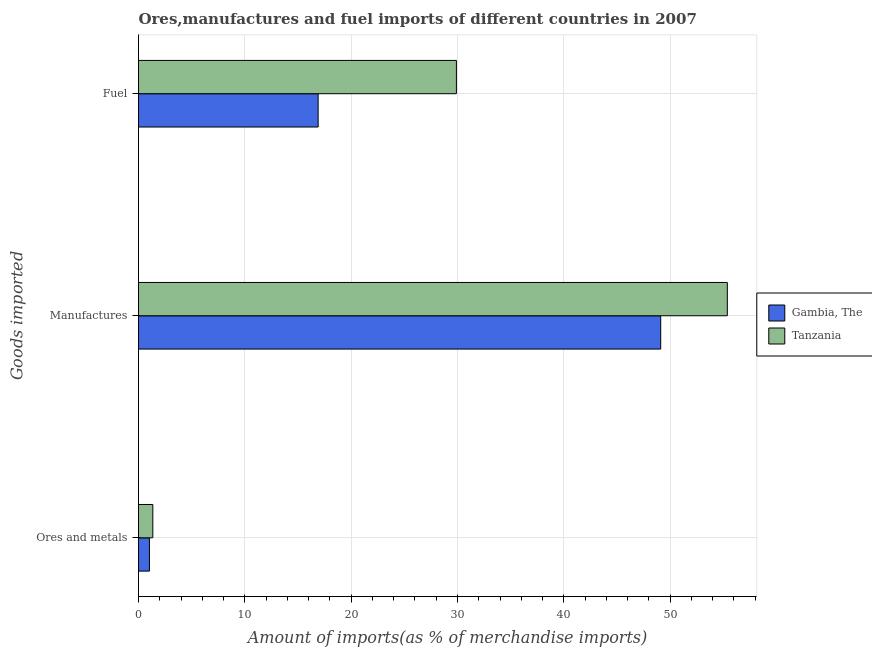Are the number of bars on each tick of the Y-axis equal?
Give a very brief answer. Yes. What is the label of the 1st group of bars from the top?
Provide a succinct answer. Fuel. What is the percentage of fuel imports in Tanzania?
Offer a terse response. 29.9. Across all countries, what is the maximum percentage of ores and metals imports?
Your answer should be very brief. 1.35. Across all countries, what is the minimum percentage of manufactures imports?
Offer a very short reply. 49.11. In which country was the percentage of fuel imports maximum?
Make the answer very short. Tanzania. In which country was the percentage of fuel imports minimum?
Make the answer very short. Gambia, The. What is the total percentage of fuel imports in the graph?
Offer a terse response. 46.79. What is the difference between the percentage of fuel imports in Tanzania and that in Gambia, The?
Give a very brief answer. 13. What is the difference between the percentage of manufactures imports in Tanzania and the percentage of fuel imports in Gambia, The?
Provide a short and direct response. 38.48. What is the average percentage of manufactures imports per country?
Your answer should be compact. 52.25. What is the difference between the percentage of manufactures imports and percentage of fuel imports in Gambia, The?
Offer a very short reply. 32.22. In how many countries, is the percentage of ores and metals imports greater than 30 %?
Ensure brevity in your answer.  0. What is the ratio of the percentage of manufactures imports in Gambia, The to that in Tanzania?
Give a very brief answer. 0.89. Is the percentage of manufactures imports in Tanzania less than that in Gambia, The?
Provide a short and direct response. No. Is the difference between the percentage of ores and metals imports in Tanzania and Gambia, The greater than the difference between the percentage of fuel imports in Tanzania and Gambia, The?
Offer a very short reply. No. What is the difference between the highest and the second highest percentage of fuel imports?
Provide a short and direct response. 13. What is the difference between the highest and the lowest percentage of ores and metals imports?
Keep it short and to the point. 0.32. What does the 1st bar from the top in Manufactures represents?
Make the answer very short. Tanzania. What does the 2nd bar from the bottom in Fuel represents?
Your answer should be compact. Tanzania. Is it the case that in every country, the sum of the percentage of ores and metals imports and percentage of manufactures imports is greater than the percentage of fuel imports?
Offer a very short reply. Yes. How many bars are there?
Offer a very short reply. 6. What is the difference between two consecutive major ticks on the X-axis?
Your response must be concise. 10. Does the graph contain any zero values?
Provide a short and direct response. No. How many legend labels are there?
Provide a succinct answer. 2. How are the legend labels stacked?
Make the answer very short. Vertical. What is the title of the graph?
Ensure brevity in your answer.  Ores,manufactures and fuel imports of different countries in 2007. Does "Morocco" appear as one of the legend labels in the graph?
Provide a succinct answer. No. What is the label or title of the X-axis?
Your answer should be compact. Amount of imports(as % of merchandise imports). What is the label or title of the Y-axis?
Offer a very short reply. Goods imported. What is the Amount of imports(as % of merchandise imports) in Gambia, The in Ores and metals?
Ensure brevity in your answer.  1.03. What is the Amount of imports(as % of merchandise imports) in Tanzania in Ores and metals?
Give a very brief answer. 1.35. What is the Amount of imports(as % of merchandise imports) of Gambia, The in Manufactures?
Your answer should be compact. 49.11. What is the Amount of imports(as % of merchandise imports) in Tanzania in Manufactures?
Keep it short and to the point. 55.38. What is the Amount of imports(as % of merchandise imports) in Gambia, The in Fuel?
Provide a short and direct response. 16.89. What is the Amount of imports(as % of merchandise imports) in Tanzania in Fuel?
Ensure brevity in your answer.  29.9. Across all Goods imported, what is the maximum Amount of imports(as % of merchandise imports) in Gambia, The?
Offer a terse response. 49.11. Across all Goods imported, what is the maximum Amount of imports(as % of merchandise imports) in Tanzania?
Offer a very short reply. 55.38. Across all Goods imported, what is the minimum Amount of imports(as % of merchandise imports) of Gambia, The?
Give a very brief answer. 1.03. Across all Goods imported, what is the minimum Amount of imports(as % of merchandise imports) in Tanzania?
Your response must be concise. 1.35. What is the total Amount of imports(as % of merchandise imports) in Gambia, The in the graph?
Your answer should be very brief. 67.04. What is the total Amount of imports(as % of merchandise imports) of Tanzania in the graph?
Keep it short and to the point. 86.62. What is the difference between the Amount of imports(as % of merchandise imports) in Gambia, The in Ores and metals and that in Manufactures?
Ensure brevity in your answer.  -48.08. What is the difference between the Amount of imports(as % of merchandise imports) in Tanzania in Ores and metals and that in Manufactures?
Give a very brief answer. -54.03. What is the difference between the Amount of imports(as % of merchandise imports) of Gambia, The in Ores and metals and that in Fuel?
Provide a succinct answer. -15.87. What is the difference between the Amount of imports(as % of merchandise imports) of Tanzania in Ores and metals and that in Fuel?
Ensure brevity in your answer.  -28.55. What is the difference between the Amount of imports(as % of merchandise imports) in Gambia, The in Manufactures and that in Fuel?
Keep it short and to the point. 32.22. What is the difference between the Amount of imports(as % of merchandise imports) in Tanzania in Manufactures and that in Fuel?
Provide a succinct answer. 25.48. What is the difference between the Amount of imports(as % of merchandise imports) in Gambia, The in Ores and metals and the Amount of imports(as % of merchandise imports) in Tanzania in Manufactures?
Your response must be concise. -54.35. What is the difference between the Amount of imports(as % of merchandise imports) in Gambia, The in Ores and metals and the Amount of imports(as % of merchandise imports) in Tanzania in Fuel?
Your answer should be compact. -28.87. What is the difference between the Amount of imports(as % of merchandise imports) of Gambia, The in Manufactures and the Amount of imports(as % of merchandise imports) of Tanzania in Fuel?
Your response must be concise. 19.21. What is the average Amount of imports(as % of merchandise imports) in Gambia, The per Goods imported?
Ensure brevity in your answer.  22.35. What is the average Amount of imports(as % of merchandise imports) of Tanzania per Goods imported?
Your response must be concise. 28.87. What is the difference between the Amount of imports(as % of merchandise imports) of Gambia, The and Amount of imports(as % of merchandise imports) of Tanzania in Ores and metals?
Offer a very short reply. -0.32. What is the difference between the Amount of imports(as % of merchandise imports) of Gambia, The and Amount of imports(as % of merchandise imports) of Tanzania in Manufactures?
Make the answer very short. -6.27. What is the difference between the Amount of imports(as % of merchandise imports) of Gambia, The and Amount of imports(as % of merchandise imports) of Tanzania in Fuel?
Your answer should be compact. -13. What is the ratio of the Amount of imports(as % of merchandise imports) in Gambia, The in Ores and metals to that in Manufactures?
Your answer should be very brief. 0.02. What is the ratio of the Amount of imports(as % of merchandise imports) of Tanzania in Ores and metals to that in Manufactures?
Provide a short and direct response. 0.02. What is the ratio of the Amount of imports(as % of merchandise imports) of Gambia, The in Ores and metals to that in Fuel?
Keep it short and to the point. 0.06. What is the ratio of the Amount of imports(as % of merchandise imports) in Tanzania in Ores and metals to that in Fuel?
Provide a short and direct response. 0.04. What is the ratio of the Amount of imports(as % of merchandise imports) of Gambia, The in Manufactures to that in Fuel?
Your response must be concise. 2.91. What is the ratio of the Amount of imports(as % of merchandise imports) in Tanzania in Manufactures to that in Fuel?
Your answer should be compact. 1.85. What is the difference between the highest and the second highest Amount of imports(as % of merchandise imports) in Gambia, The?
Keep it short and to the point. 32.22. What is the difference between the highest and the second highest Amount of imports(as % of merchandise imports) of Tanzania?
Provide a succinct answer. 25.48. What is the difference between the highest and the lowest Amount of imports(as % of merchandise imports) in Gambia, The?
Provide a short and direct response. 48.08. What is the difference between the highest and the lowest Amount of imports(as % of merchandise imports) of Tanzania?
Offer a terse response. 54.03. 